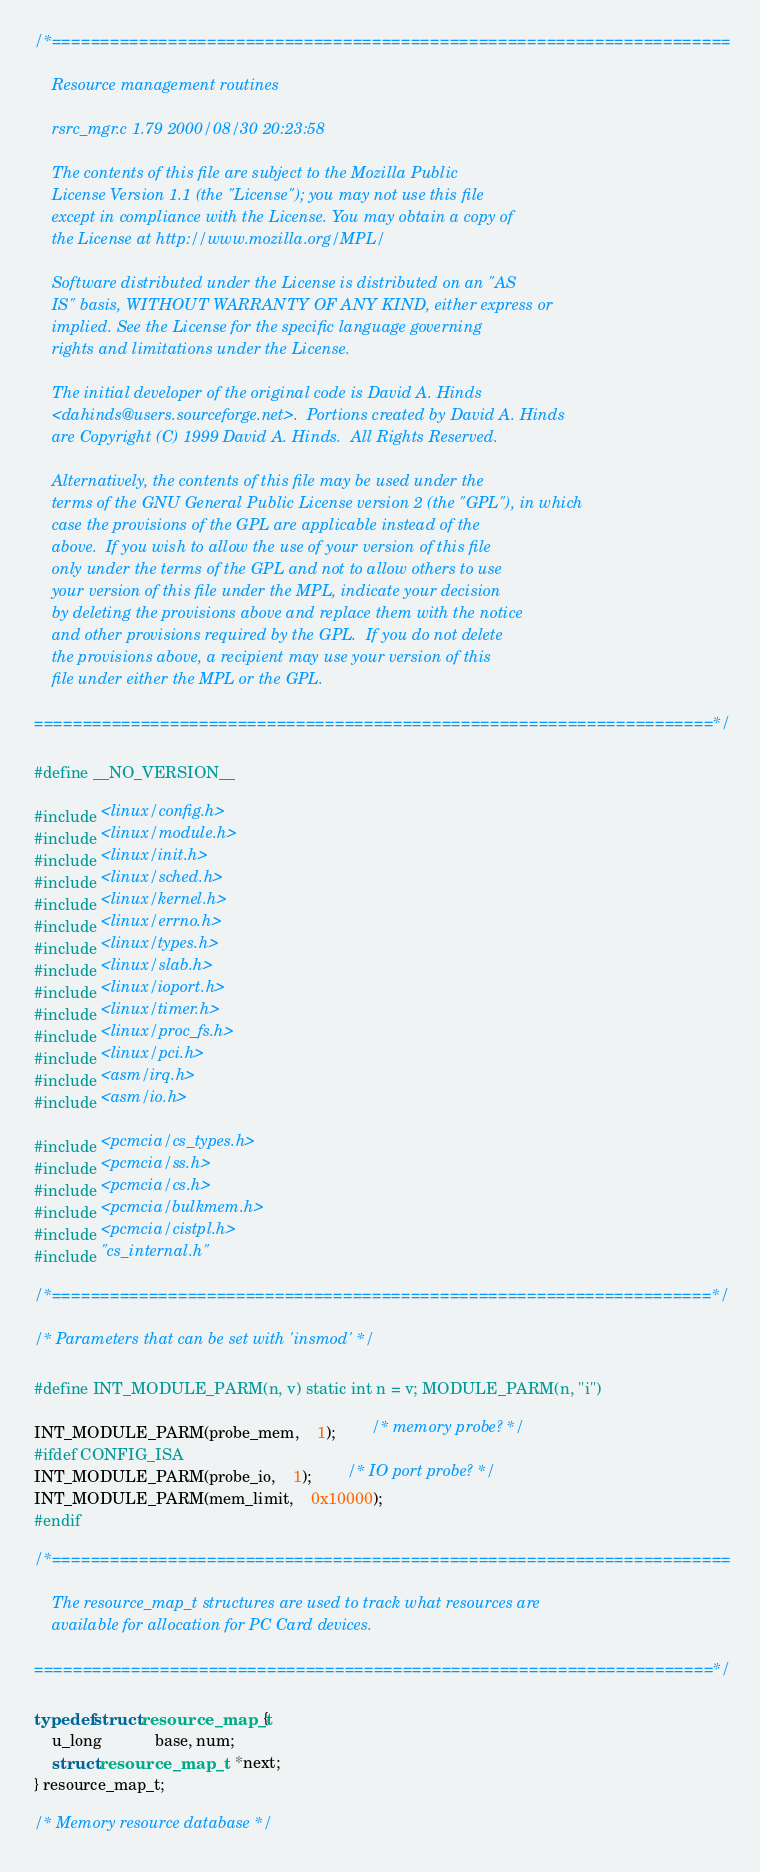Convert code to text. <code><loc_0><loc_0><loc_500><loc_500><_C_>/*======================================================================

    Resource management routines

    rsrc_mgr.c 1.79 2000/08/30 20:23:58

    The contents of this file are subject to the Mozilla Public
    License Version 1.1 (the "License"); you may not use this file
    except in compliance with the License. You may obtain a copy of
    the License at http://www.mozilla.org/MPL/

    Software distributed under the License is distributed on an "AS
    IS" basis, WITHOUT WARRANTY OF ANY KIND, either express or
    implied. See the License for the specific language governing
    rights and limitations under the License.

    The initial developer of the original code is David A. Hinds
    <dahinds@users.sourceforge.net>.  Portions created by David A. Hinds
    are Copyright (C) 1999 David A. Hinds.  All Rights Reserved.

    Alternatively, the contents of this file may be used under the
    terms of the GNU General Public License version 2 (the "GPL"), in which
    case the provisions of the GPL are applicable instead of the
    above.  If you wish to allow the use of your version of this file
    only under the terms of the GPL and not to allow others to use
    your version of this file under the MPL, indicate your decision
    by deleting the provisions above and replace them with the notice
    and other provisions required by the GPL.  If you do not delete
    the provisions above, a recipient may use your version of this
    file under either the MPL or the GPL.
    
======================================================================*/

#define __NO_VERSION__

#include <linux/config.h>
#include <linux/module.h>
#include <linux/init.h>
#include <linux/sched.h>
#include <linux/kernel.h>
#include <linux/errno.h>
#include <linux/types.h>
#include <linux/slab.h>
#include <linux/ioport.h>
#include <linux/timer.h>
#include <linux/proc_fs.h>
#include <linux/pci.h>
#include <asm/irq.h>
#include <asm/io.h>

#include <pcmcia/cs_types.h>
#include <pcmcia/ss.h>
#include <pcmcia/cs.h>
#include <pcmcia/bulkmem.h>
#include <pcmcia/cistpl.h>
#include "cs_internal.h"

/*====================================================================*/

/* Parameters that can be set with 'insmod' */

#define INT_MODULE_PARM(n, v) static int n = v; MODULE_PARM(n, "i")

INT_MODULE_PARM(probe_mem,	1);		/* memory probe? */
#ifdef CONFIG_ISA
INT_MODULE_PARM(probe_io,	1);		/* IO port probe? */
INT_MODULE_PARM(mem_limit,	0x10000);
#endif

/*======================================================================

    The resource_map_t structures are used to track what resources are
    available for allocation for PC Card devices.

======================================================================*/

typedef struct resource_map_t {
    u_long			base, num;
    struct resource_map_t	*next;
} resource_map_t;

/* Memory resource database */</code> 